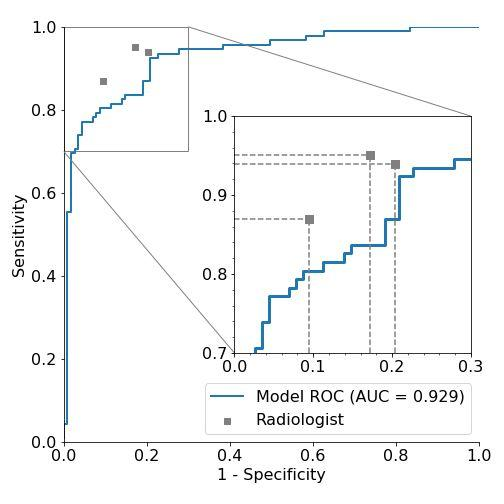Based on the AUC (Area Under the Curve) value provided in the figure, how would you classify the model's performance? A. Poor B. Fair C. Good D. Excellent The AUC value is 0.929, which is close to 1. An AUC of 1 represents a perfect test; an AUC of 0.5 suggests no discriminative power. A value of 0.929 suggests the model has excellent performance in distinguishing between the two conditions it was tested for. Therefore, the correct answer is D. 